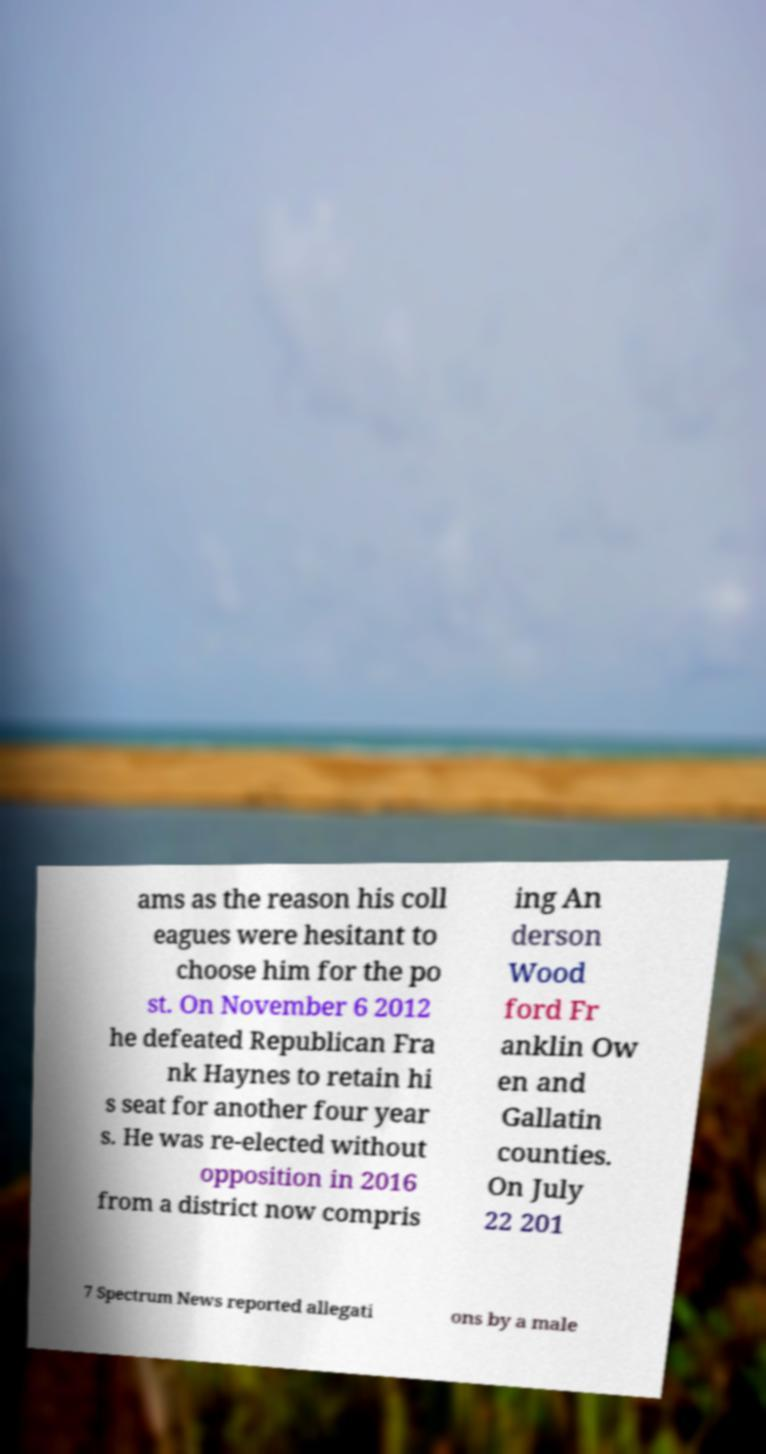There's text embedded in this image that I need extracted. Can you transcribe it verbatim? ams as the reason his coll eagues were hesitant to choose him for the po st. On November 6 2012 he defeated Republican Fra nk Haynes to retain hi s seat for another four year s. He was re-elected without opposition in 2016 from a district now compris ing An derson Wood ford Fr anklin Ow en and Gallatin counties. On July 22 201 7 Spectrum News reported allegati ons by a male 